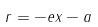<formula> <loc_0><loc_0><loc_500><loc_500>r = - e x - a</formula> 